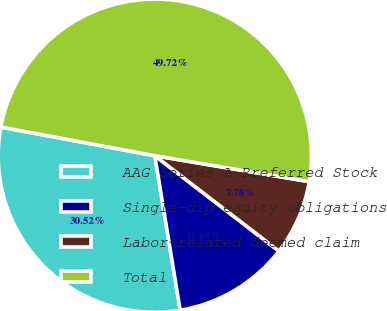Convert chart. <chart><loc_0><loc_0><loc_500><loc_500><pie_chart><fcel>AAG Series A Preferred Stock<fcel>Single-dip equity obligations<fcel>Labor-related deemed claim<fcel>Total<nl><fcel>30.52%<fcel>11.98%<fcel>7.78%<fcel>49.72%<nl></chart> 